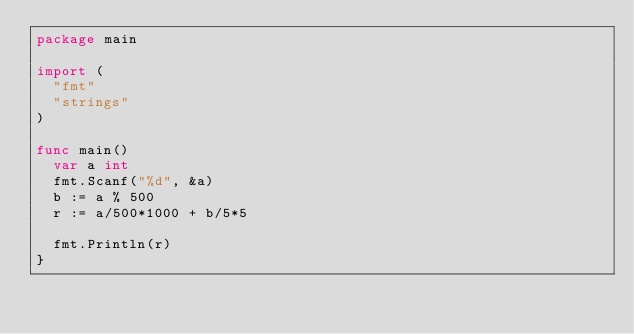<code> <loc_0><loc_0><loc_500><loc_500><_Go_>package main

import (
	"fmt"
	"strings"
)

func main() 
	var a int
	fmt.Scanf("%d", &a)
	b := a % 500
	r := a/500*1000 + b/5*5

	fmt.Println(r)
}</code> 